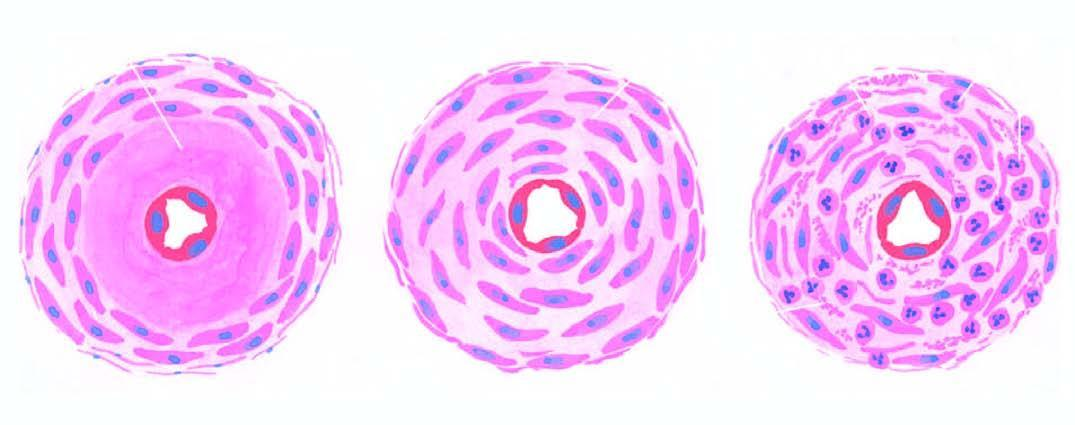s diagrammatic representation of three forms of arteriolosclerosis seen in hypertension?
Answer the question using a single word or phrase. Yes 